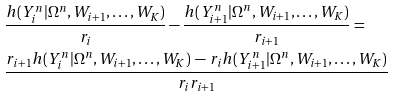<formula> <loc_0><loc_0><loc_500><loc_500>& \frac { h ( Y _ { i } ^ { n } | \Omega ^ { n } , W _ { i + 1 } , \dots , W _ { K } ) } { r _ { i } } - \frac { h ( Y _ { i + 1 } ^ { n } | \Omega ^ { n } , W _ { i + 1 } , \dots , W _ { K } ) } { r _ { i + 1 } } = \\ & \frac { r _ { i + 1 } h ( Y _ { i } ^ { n } | \Omega ^ { n } , W _ { i + 1 } , \dots , W _ { K } ) \, - \, r _ { i } h ( Y _ { i + 1 } ^ { n } | \Omega ^ { n } , W _ { i + 1 } , \dots , W _ { K } ) } { r _ { i } r _ { i + 1 } }</formula> 